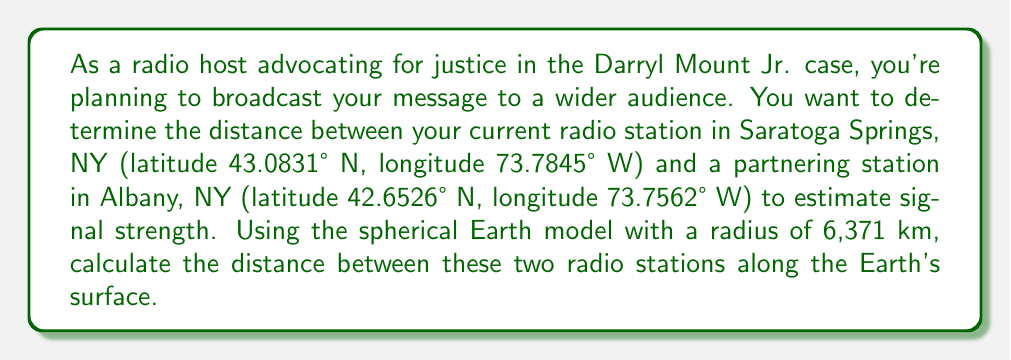Provide a solution to this math problem. To solve this problem, we'll use the Haversine formula, which calculates the great-circle distance between two points on a sphere given their latitudes and longitudes. Here are the steps:

1. Convert the latitudes and longitudes from degrees to radians:
   $$\phi_1 = 43.0831° \cdot \frac{\pi}{180} = 0.7518 \text{ rad}$$
   $$\lambda_1 = -73.7845° \cdot \frac{\pi}{180} = -1.2877 \text{ rad}$$
   $$\phi_2 = 42.6526° \cdot \frac{\pi}{180} = 0.7443 \text{ rad}$$
   $$\lambda_2 = -73.7562° \cdot \frac{\pi}{180} = -1.2872 \text{ rad}$$

2. Calculate the differences in latitude and longitude:
   $$\Delta\phi = \phi_2 - \phi_1 = -0.0075 \text{ rad}$$
   $$\Delta\lambda = \lambda_2 - \lambda_1 = 0.0005 \text{ rad}$$

3. Apply the Haversine formula:
   $$a = \sin^2(\frac{\Delta\phi}{2}) + \cos(\phi_1) \cos(\phi_2) \sin^2(\frac{\Delta\lambda}{2})$$
   $$c = 2 \arctan2(\sqrt{a}, \sqrt{1-a})$$
   $$d = R \cdot c$$

   Where $R$ is the Earth's radius (6,371 km).

4. Calculate $a$:
   $$a = \sin^2(-0.00375) + \cos(0.7518) \cos(0.7443) \sin^2(0.00025)$$
   $$a = 1.4063 \times 10^{-5}$$

5. Calculate $c$:
   $$c = 2 \arctan2(\sqrt{1.4063 \times 10^{-5}}, \sqrt{1 - 1.4063 \times 10^{-5}})$$
   $$c = 0.0075$$

6. Calculate the distance $d$:
   $$d = 6371 \cdot 0.0075 = 47.7825 \text{ km}$$

Therefore, the distance between the two radio stations is approximately 47.78 km.
Answer: 47.78 km 